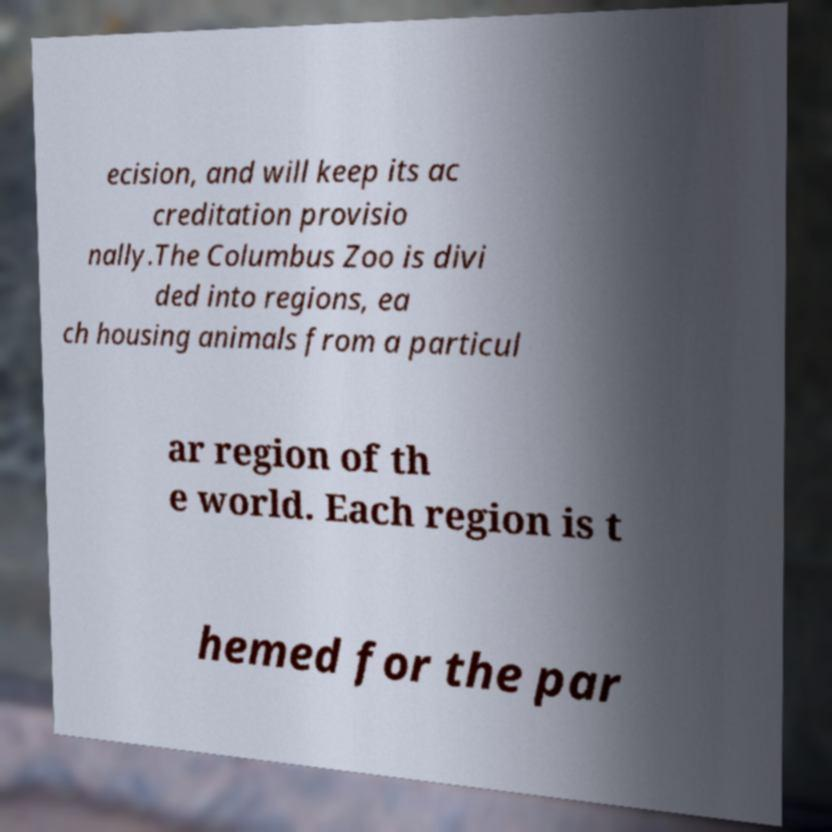Could you assist in decoding the text presented in this image and type it out clearly? ecision, and will keep its ac creditation provisio nally.The Columbus Zoo is divi ded into regions, ea ch housing animals from a particul ar region of th e world. Each region is t hemed for the par 